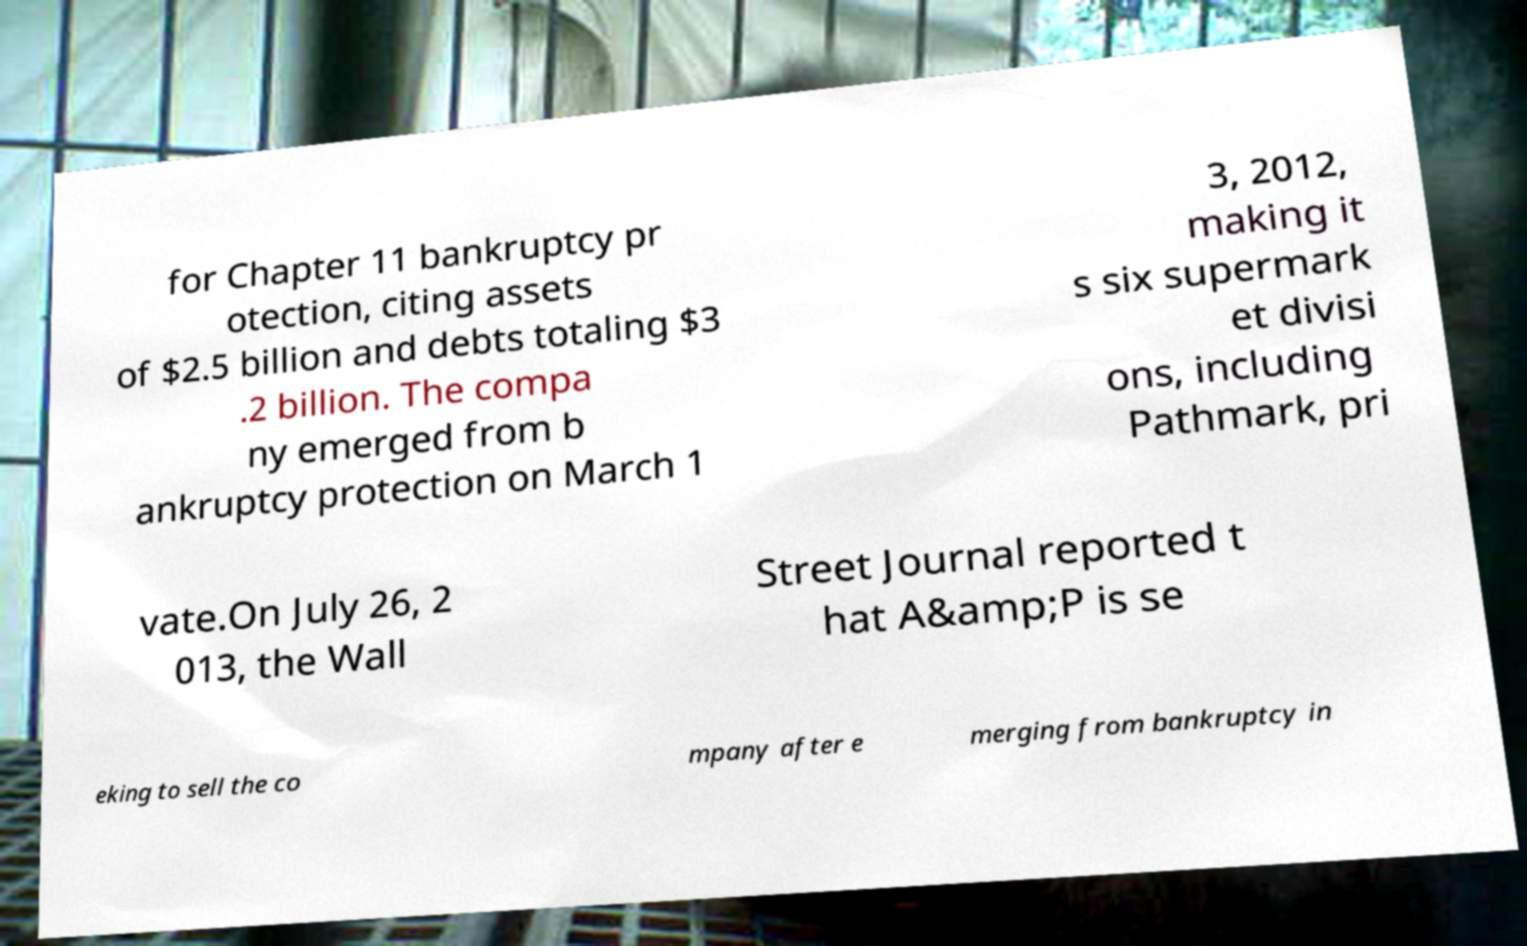Could you extract and type out the text from this image? for Chapter 11 bankruptcy pr otection, citing assets of $2.5 billion and debts totaling $3 .2 billion. The compa ny emerged from b ankruptcy protection on March 1 3, 2012, making it s six supermark et divisi ons, including Pathmark, pri vate.On July 26, 2 013, the Wall Street Journal reported t hat A&amp;P is se eking to sell the co mpany after e merging from bankruptcy in 